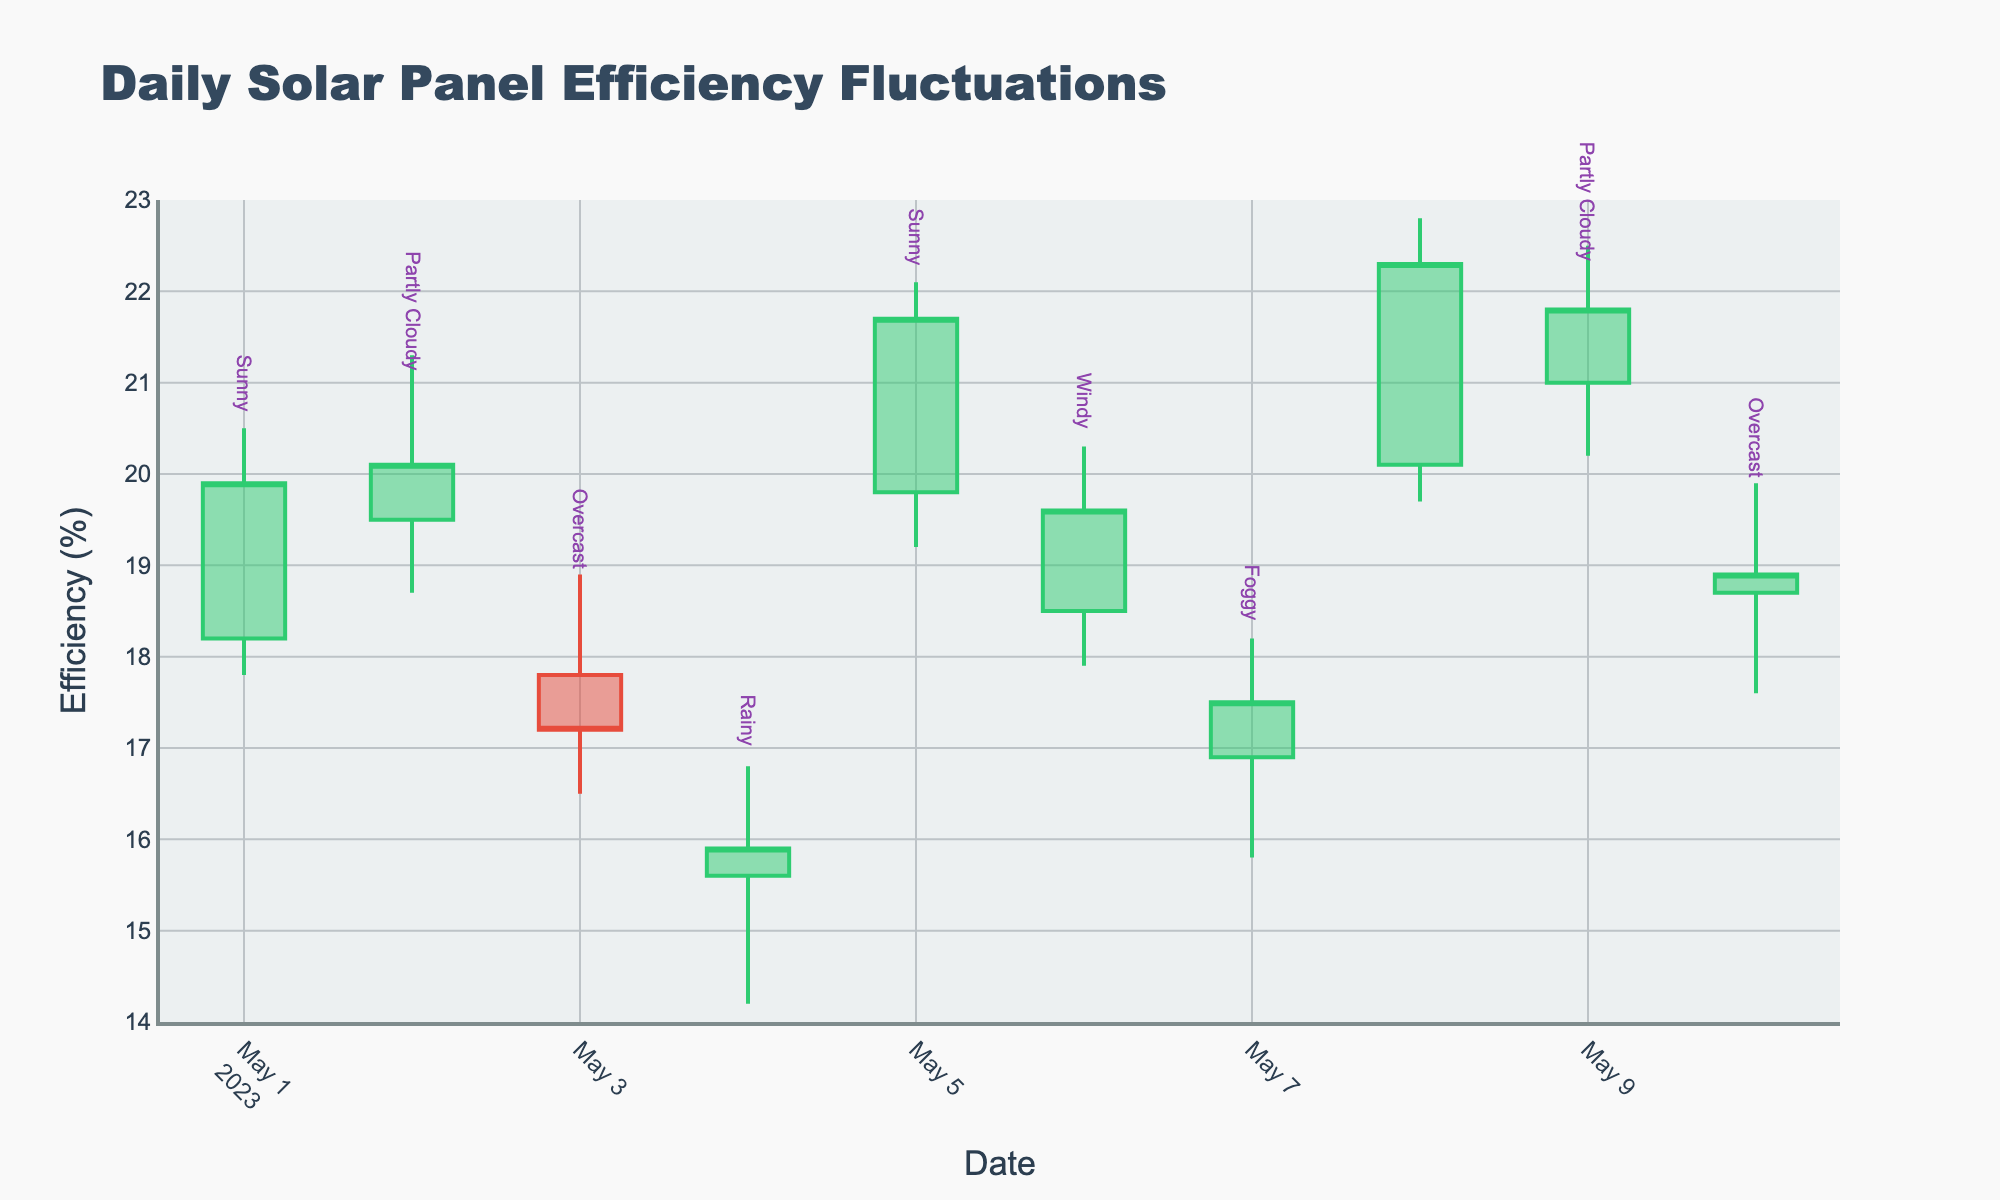What is the highest solar panel efficiency recorded on any day? Look at the 'High' value for each day and identify the maximum. The highest recorded efficiency is on May 8th with a value of 22.8%.
Answer: 22.8% Which weather condition corresponds to the lowest closing efficiency? Locate the lowest 'Close' value across all days. The lowest closing efficiency is on May 3rd with a value of 17.2%, which corresponds to the 'Overcast' weather.
Answer: Overcast On which date did the solar panel efficiency have the greatest increase from open to close? Calculate the difference between 'Close' and 'Open' for each day and find the maximum difference. The greatest increase is on May 1st with (19.9 - 18.2) = 1.7.
Answer: May 1 Which weather condition showed the smallest range in solar panel efficiency? Calculate the range (High - Low) for each day and identify the smallest range. The smallest range is on May 10th with a range of (19.9 - 17.6) = 2.3, under 'Overcast' weather.
Answer: Overcast How many days had an 'Open' efficiency greater than 20%? Count the days where the 'Open' value is greater than 20. There are two such days: May 8th and May 9th.
Answer: 2 What was the efficiency value on May 4th? Refer to the 'Close' value for May 4th. The efficiency value is 15.9%.
Answer: 15.9% Which day experienced the most significant drop in efficiency from the highest point to the closing value? Calculate the difference between 'High' and 'Close' for each day and find the maximum drop. The most significant drop occurs on May 9th with a difference of (22.5 - 21.8) = 0.7.
Answer: May 9 Compare the average closing efficiency of 'Sunny' days to 'Overcast' days. Which one is higher? Calculate the average 'Close' value for 'Sunny' days (May 1, May 5, and May 8) and 'Overcast' days (May 3 and May 10). Average for 'Sunny' is [(19.9 + 21.7 + 22.3) / 3] = 21.3 and for 'Overcast' is [(17.2 + 18.9) / 2] = 18.05. Therefore, 'Sunny' days have a higher average closing efficiency.
Answer: Sunny What weather condition was recorded on May 7th, and what was the 'High' efficiency value for that day? Refer to the data for May 7th. The weather condition is 'Foggy', and the 'High' efficiency value is 18.2%.
Answer: Foggy, 18.2% 